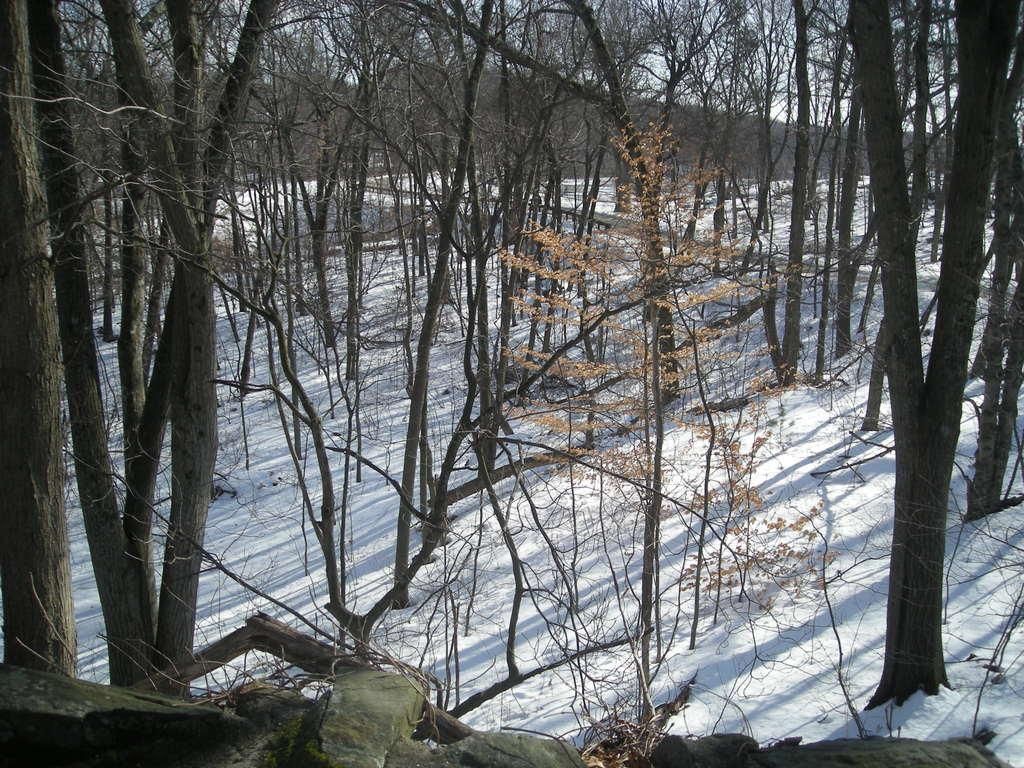What type of vegetation is present in the image? There is a group of trees in the image. What is covering the ground at the bottom of the image? There is snow at the bottom of the image. What can be seen in the distance in the image? There are mountains in the background of the image. What is visible above the mountains in the image? The sky is visible in the background of the image. What type of meat is being sold in the shop in the image? There is no shop present in the image, so it is not possible to determine what type of meat might be sold. What kind of furniture can be seen in the image? There is no furniture present in the image; it features a group of trees, snow, mountains, and the sky. 